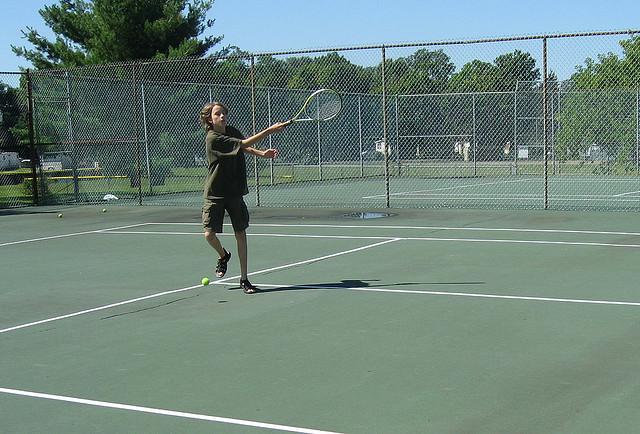Is the boy casting a shadow on the court?
Give a very brief answer. Yes. What is the person playing?
Short answer required. Tennis. Is it daytime?
Give a very brief answer. Yes. What does the boy have on his tennis racket?
Concise answer only. Nothing. How many courts can be seen in the photo?
Give a very brief answer. 2. 